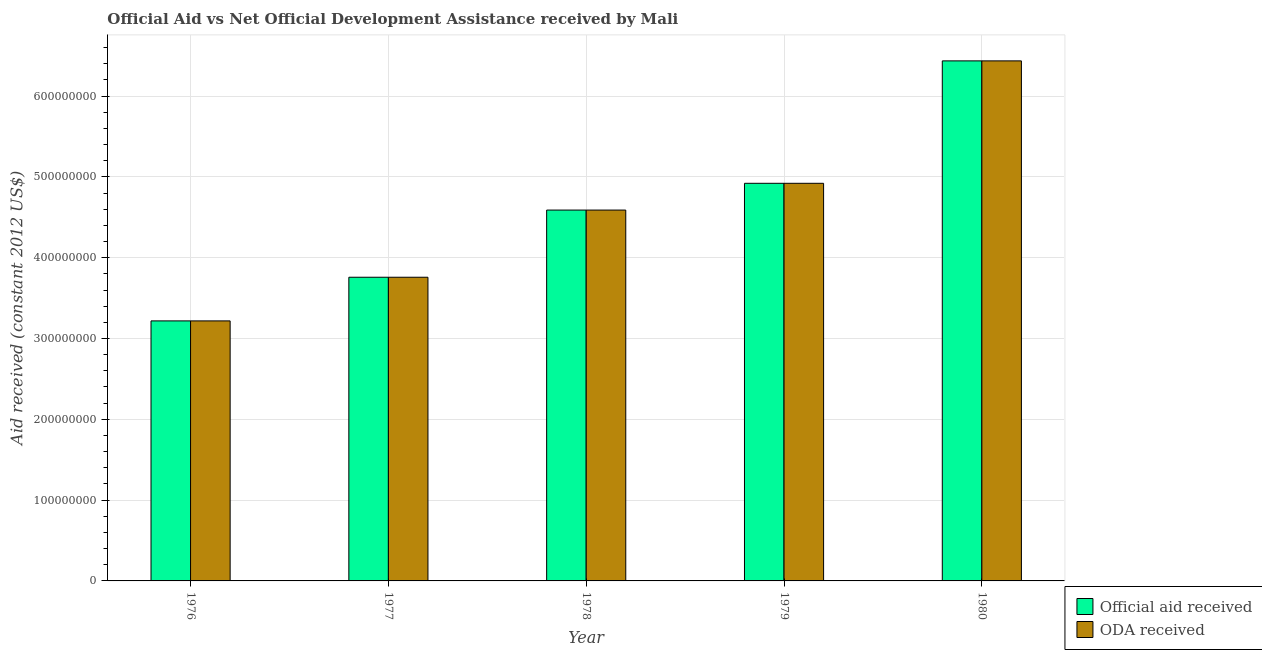How many bars are there on the 2nd tick from the left?
Make the answer very short. 2. What is the label of the 3rd group of bars from the left?
Offer a terse response. 1978. In how many cases, is the number of bars for a given year not equal to the number of legend labels?
Your answer should be very brief. 0. What is the official aid received in 1976?
Provide a succinct answer. 3.22e+08. Across all years, what is the maximum official aid received?
Provide a short and direct response. 6.44e+08. Across all years, what is the minimum official aid received?
Keep it short and to the point. 3.22e+08. In which year was the official aid received maximum?
Ensure brevity in your answer.  1980. In which year was the oda received minimum?
Give a very brief answer. 1976. What is the total oda received in the graph?
Your answer should be compact. 2.29e+09. What is the difference between the oda received in 1978 and that in 1980?
Make the answer very short. -1.85e+08. What is the difference between the official aid received in 1977 and the oda received in 1980?
Ensure brevity in your answer.  -2.68e+08. What is the average official aid received per year?
Your answer should be compact. 4.58e+08. What is the ratio of the official aid received in 1977 to that in 1978?
Give a very brief answer. 0.82. Is the oda received in 1978 less than that in 1980?
Offer a terse response. Yes. Is the difference between the oda received in 1976 and 1980 greater than the difference between the official aid received in 1976 and 1980?
Keep it short and to the point. No. What is the difference between the highest and the second highest oda received?
Provide a short and direct response. 1.52e+08. What is the difference between the highest and the lowest oda received?
Provide a succinct answer. 3.22e+08. What does the 1st bar from the left in 1980 represents?
Provide a succinct answer. Official aid received. What does the 1st bar from the right in 1977 represents?
Give a very brief answer. ODA received. How many bars are there?
Make the answer very short. 10. Are all the bars in the graph horizontal?
Your response must be concise. No. How many years are there in the graph?
Keep it short and to the point. 5. Does the graph contain grids?
Provide a succinct answer. Yes. How many legend labels are there?
Give a very brief answer. 2. How are the legend labels stacked?
Give a very brief answer. Vertical. What is the title of the graph?
Offer a terse response. Official Aid vs Net Official Development Assistance received by Mali . What is the label or title of the Y-axis?
Provide a succinct answer. Aid received (constant 2012 US$). What is the Aid received (constant 2012 US$) of Official aid received in 1976?
Offer a very short reply. 3.22e+08. What is the Aid received (constant 2012 US$) in ODA received in 1976?
Provide a short and direct response. 3.22e+08. What is the Aid received (constant 2012 US$) of Official aid received in 1977?
Offer a terse response. 3.76e+08. What is the Aid received (constant 2012 US$) of ODA received in 1977?
Offer a terse response. 3.76e+08. What is the Aid received (constant 2012 US$) of Official aid received in 1978?
Make the answer very short. 4.59e+08. What is the Aid received (constant 2012 US$) in ODA received in 1978?
Make the answer very short. 4.59e+08. What is the Aid received (constant 2012 US$) of Official aid received in 1979?
Give a very brief answer. 4.92e+08. What is the Aid received (constant 2012 US$) in ODA received in 1979?
Give a very brief answer. 4.92e+08. What is the Aid received (constant 2012 US$) of Official aid received in 1980?
Offer a very short reply. 6.44e+08. What is the Aid received (constant 2012 US$) in ODA received in 1980?
Keep it short and to the point. 6.44e+08. Across all years, what is the maximum Aid received (constant 2012 US$) of Official aid received?
Keep it short and to the point. 6.44e+08. Across all years, what is the maximum Aid received (constant 2012 US$) in ODA received?
Offer a very short reply. 6.44e+08. Across all years, what is the minimum Aid received (constant 2012 US$) in Official aid received?
Ensure brevity in your answer.  3.22e+08. Across all years, what is the minimum Aid received (constant 2012 US$) in ODA received?
Provide a short and direct response. 3.22e+08. What is the total Aid received (constant 2012 US$) in Official aid received in the graph?
Offer a terse response. 2.29e+09. What is the total Aid received (constant 2012 US$) of ODA received in the graph?
Give a very brief answer. 2.29e+09. What is the difference between the Aid received (constant 2012 US$) of Official aid received in 1976 and that in 1977?
Make the answer very short. -5.40e+07. What is the difference between the Aid received (constant 2012 US$) in ODA received in 1976 and that in 1977?
Your response must be concise. -5.40e+07. What is the difference between the Aid received (constant 2012 US$) in Official aid received in 1976 and that in 1978?
Make the answer very short. -1.37e+08. What is the difference between the Aid received (constant 2012 US$) of ODA received in 1976 and that in 1978?
Make the answer very short. -1.37e+08. What is the difference between the Aid received (constant 2012 US$) in Official aid received in 1976 and that in 1979?
Provide a short and direct response. -1.70e+08. What is the difference between the Aid received (constant 2012 US$) of ODA received in 1976 and that in 1979?
Give a very brief answer. -1.70e+08. What is the difference between the Aid received (constant 2012 US$) of Official aid received in 1976 and that in 1980?
Offer a very short reply. -3.22e+08. What is the difference between the Aid received (constant 2012 US$) in ODA received in 1976 and that in 1980?
Your answer should be compact. -3.22e+08. What is the difference between the Aid received (constant 2012 US$) of Official aid received in 1977 and that in 1978?
Your response must be concise. -8.31e+07. What is the difference between the Aid received (constant 2012 US$) in ODA received in 1977 and that in 1978?
Your response must be concise. -8.31e+07. What is the difference between the Aid received (constant 2012 US$) of Official aid received in 1977 and that in 1979?
Your answer should be very brief. -1.16e+08. What is the difference between the Aid received (constant 2012 US$) in ODA received in 1977 and that in 1979?
Your answer should be compact. -1.16e+08. What is the difference between the Aid received (constant 2012 US$) of Official aid received in 1977 and that in 1980?
Offer a terse response. -2.68e+08. What is the difference between the Aid received (constant 2012 US$) in ODA received in 1977 and that in 1980?
Provide a succinct answer. -2.68e+08. What is the difference between the Aid received (constant 2012 US$) of Official aid received in 1978 and that in 1979?
Give a very brief answer. -3.31e+07. What is the difference between the Aid received (constant 2012 US$) of ODA received in 1978 and that in 1979?
Your answer should be very brief. -3.31e+07. What is the difference between the Aid received (constant 2012 US$) in Official aid received in 1978 and that in 1980?
Offer a terse response. -1.85e+08. What is the difference between the Aid received (constant 2012 US$) in ODA received in 1978 and that in 1980?
Keep it short and to the point. -1.85e+08. What is the difference between the Aid received (constant 2012 US$) of Official aid received in 1979 and that in 1980?
Ensure brevity in your answer.  -1.52e+08. What is the difference between the Aid received (constant 2012 US$) of ODA received in 1979 and that in 1980?
Make the answer very short. -1.52e+08. What is the difference between the Aid received (constant 2012 US$) of Official aid received in 1976 and the Aid received (constant 2012 US$) of ODA received in 1977?
Ensure brevity in your answer.  -5.40e+07. What is the difference between the Aid received (constant 2012 US$) in Official aid received in 1976 and the Aid received (constant 2012 US$) in ODA received in 1978?
Provide a short and direct response. -1.37e+08. What is the difference between the Aid received (constant 2012 US$) of Official aid received in 1976 and the Aid received (constant 2012 US$) of ODA received in 1979?
Provide a succinct answer. -1.70e+08. What is the difference between the Aid received (constant 2012 US$) of Official aid received in 1976 and the Aid received (constant 2012 US$) of ODA received in 1980?
Provide a succinct answer. -3.22e+08. What is the difference between the Aid received (constant 2012 US$) in Official aid received in 1977 and the Aid received (constant 2012 US$) in ODA received in 1978?
Provide a succinct answer. -8.31e+07. What is the difference between the Aid received (constant 2012 US$) of Official aid received in 1977 and the Aid received (constant 2012 US$) of ODA received in 1979?
Your answer should be compact. -1.16e+08. What is the difference between the Aid received (constant 2012 US$) in Official aid received in 1977 and the Aid received (constant 2012 US$) in ODA received in 1980?
Your answer should be compact. -2.68e+08. What is the difference between the Aid received (constant 2012 US$) in Official aid received in 1978 and the Aid received (constant 2012 US$) in ODA received in 1979?
Provide a short and direct response. -3.31e+07. What is the difference between the Aid received (constant 2012 US$) of Official aid received in 1978 and the Aid received (constant 2012 US$) of ODA received in 1980?
Provide a short and direct response. -1.85e+08. What is the difference between the Aid received (constant 2012 US$) in Official aid received in 1979 and the Aid received (constant 2012 US$) in ODA received in 1980?
Keep it short and to the point. -1.52e+08. What is the average Aid received (constant 2012 US$) in Official aid received per year?
Your answer should be compact. 4.58e+08. What is the average Aid received (constant 2012 US$) in ODA received per year?
Your answer should be compact. 4.58e+08. In the year 1976, what is the difference between the Aid received (constant 2012 US$) of Official aid received and Aid received (constant 2012 US$) of ODA received?
Offer a very short reply. 0. In the year 1977, what is the difference between the Aid received (constant 2012 US$) in Official aid received and Aid received (constant 2012 US$) in ODA received?
Ensure brevity in your answer.  0. In the year 1979, what is the difference between the Aid received (constant 2012 US$) of Official aid received and Aid received (constant 2012 US$) of ODA received?
Give a very brief answer. 0. In the year 1980, what is the difference between the Aid received (constant 2012 US$) in Official aid received and Aid received (constant 2012 US$) in ODA received?
Your response must be concise. 0. What is the ratio of the Aid received (constant 2012 US$) of Official aid received in 1976 to that in 1977?
Give a very brief answer. 0.86. What is the ratio of the Aid received (constant 2012 US$) in ODA received in 1976 to that in 1977?
Keep it short and to the point. 0.86. What is the ratio of the Aid received (constant 2012 US$) in Official aid received in 1976 to that in 1978?
Your answer should be very brief. 0.7. What is the ratio of the Aid received (constant 2012 US$) of ODA received in 1976 to that in 1978?
Provide a short and direct response. 0.7. What is the ratio of the Aid received (constant 2012 US$) in Official aid received in 1976 to that in 1979?
Your response must be concise. 0.65. What is the ratio of the Aid received (constant 2012 US$) of ODA received in 1976 to that in 1979?
Give a very brief answer. 0.65. What is the ratio of the Aid received (constant 2012 US$) of Official aid received in 1977 to that in 1978?
Offer a terse response. 0.82. What is the ratio of the Aid received (constant 2012 US$) of ODA received in 1977 to that in 1978?
Your answer should be very brief. 0.82. What is the ratio of the Aid received (constant 2012 US$) of Official aid received in 1977 to that in 1979?
Offer a very short reply. 0.76. What is the ratio of the Aid received (constant 2012 US$) of ODA received in 1977 to that in 1979?
Your response must be concise. 0.76. What is the ratio of the Aid received (constant 2012 US$) in Official aid received in 1977 to that in 1980?
Keep it short and to the point. 0.58. What is the ratio of the Aid received (constant 2012 US$) of ODA received in 1977 to that in 1980?
Your response must be concise. 0.58. What is the ratio of the Aid received (constant 2012 US$) in Official aid received in 1978 to that in 1979?
Offer a terse response. 0.93. What is the ratio of the Aid received (constant 2012 US$) of ODA received in 1978 to that in 1979?
Offer a very short reply. 0.93. What is the ratio of the Aid received (constant 2012 US$) of Official aid received in 1978 to that in 1980?
Your answer should be compact. 0.71. What is the ratio of the Aid received (constant 2012 US$) of ODA received in 1978 to that in 1980?
Give a very brief answer. 0.71. What is the ratio of the Aid received (constant 2012 US$) of Official aid received in 1979 to that in 1980?
Offer a very short reply. 0.76. What is the ratio of the Aid received (constant 2012 US$) in ODA received in 1979 to that in 1980?
Offer a very short reply. 0.76. What is the difference between the highest and the second highest Aid received (constant 2012 US$) of Official aid received?
Ensure brevity in your answer.  1.52e+08. What is the difference between the highest and the second highest Aid received (constant 2012 US$) in ODA received?
Offer a very short reply. 1.52e+08. What is the difference between the highest and the lowest Aid received (constant 2012 US$) of Official aid received?
Your answer should be very brief. 3.22e+08. What is the difference between the highest and the lowest Aid received (constant 2012 US$) of ODA received?
Provide a short and direct response. 3.22e+08. 